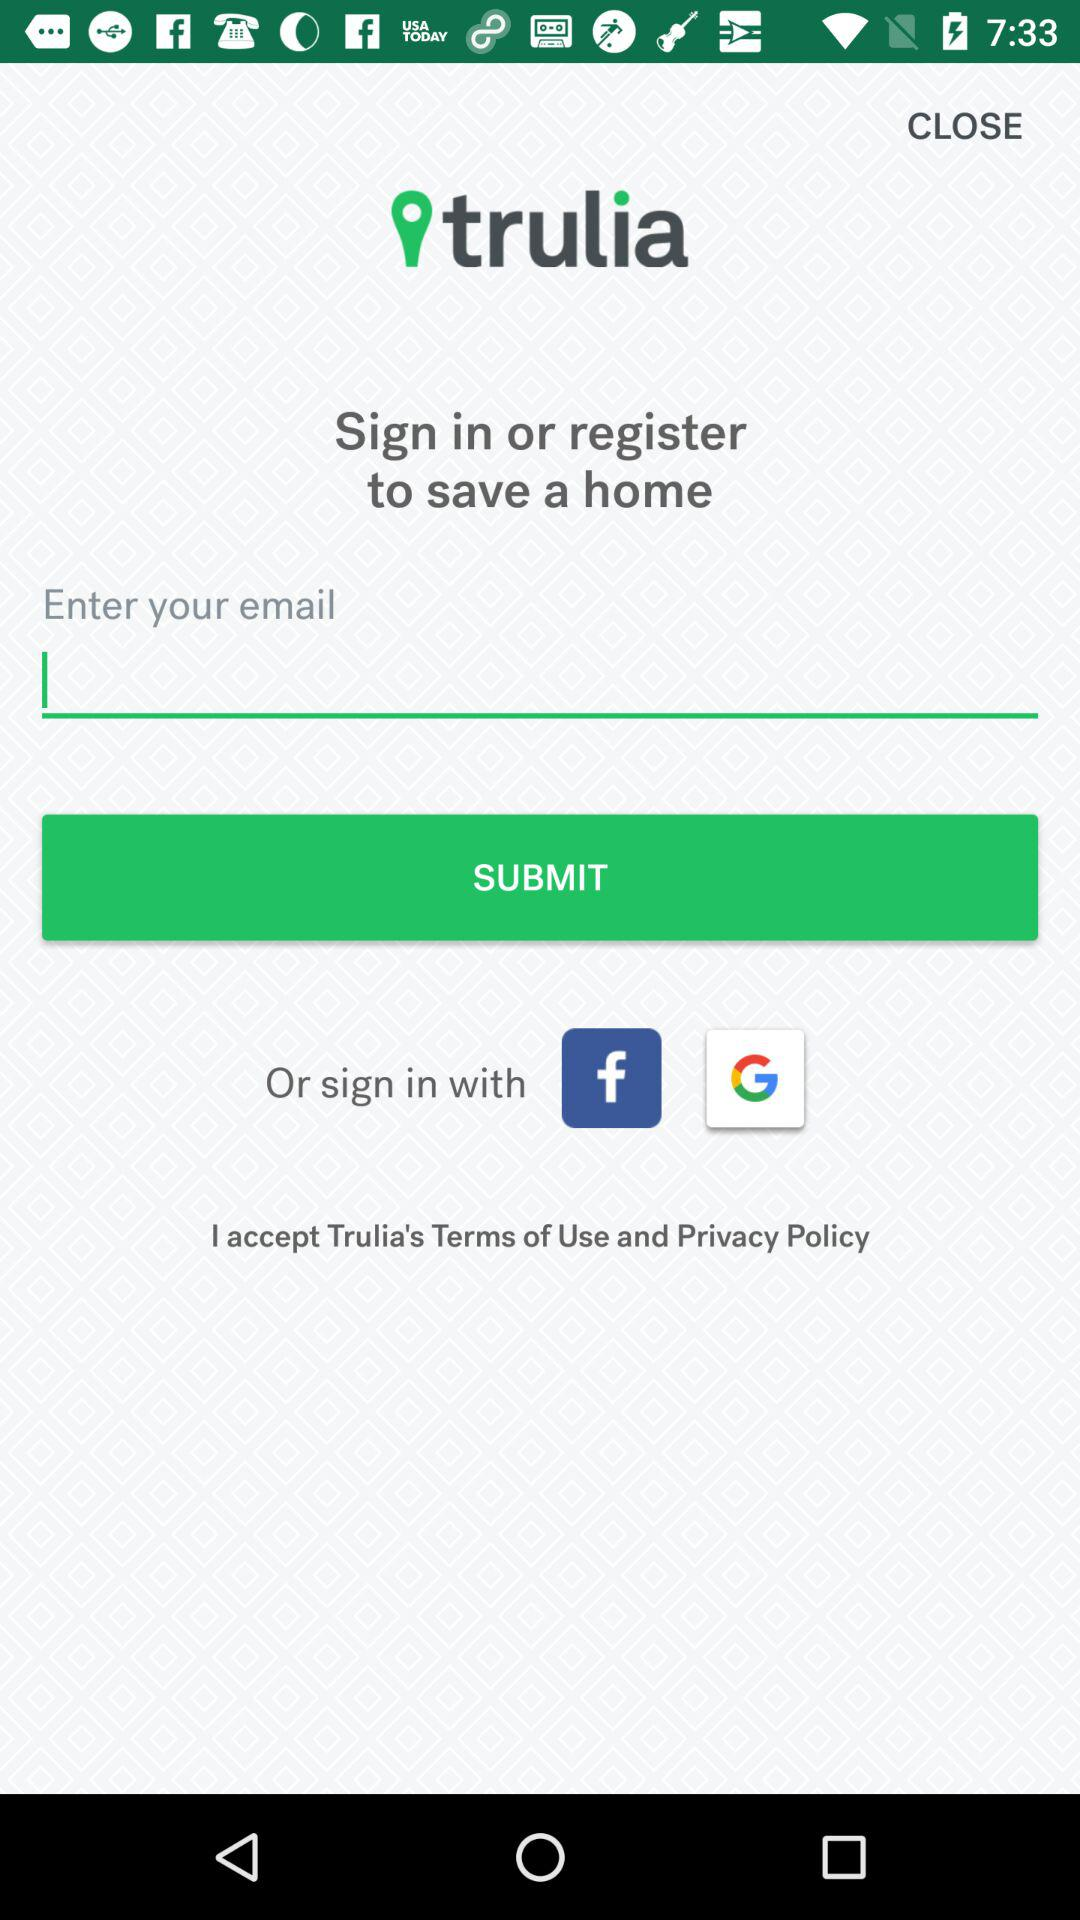How many more social media sign in options are there than text input boxes?
Answer the question using a single word or phrase. 2 